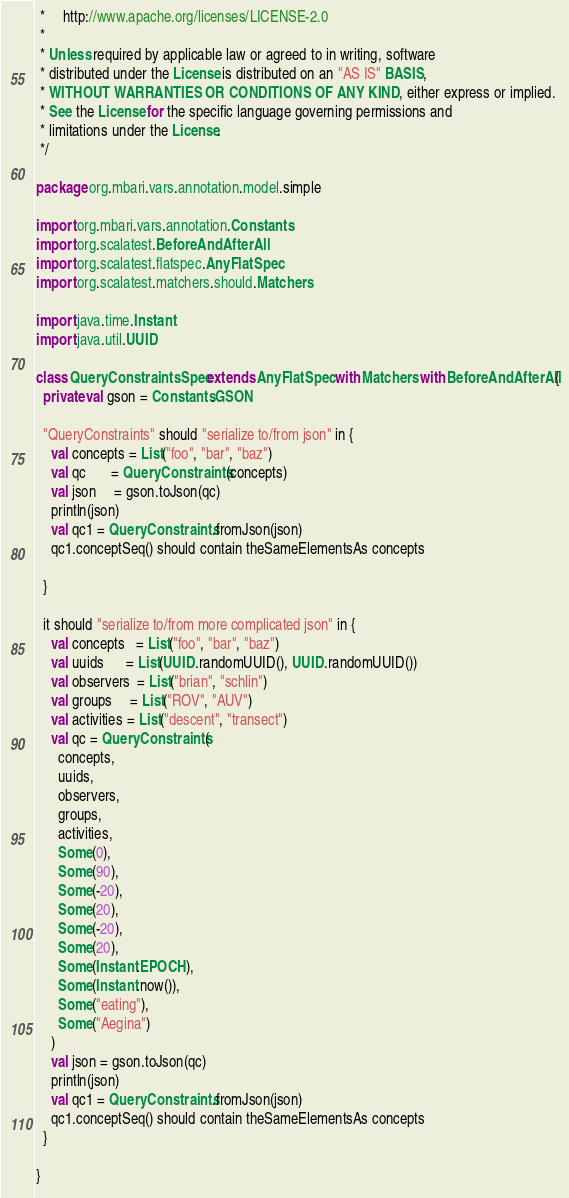<code> <loc_0><loc_0><loc_500><loc_500><_Scala_> *     http://www.apache.org/licenses/LICENSE-2.0
 *
 * Unless required by applicable law or agreed to in writing, software
 * distributed under the License is distributed on an "AS IS" BASIS,
 * WITHOUT WARRANTIES OR CONDITIONS OF ANY KIND, either express or implied.
 * See the License for the specific language governing permissions and
 * limitations under the License.
 */

package org.mbari.vars.annotation.model.simple

import org.mbari.vars.annotation.Constants
import org.scalatest.BeforeAndAfterAll
import org.scalatest.flatspec.AnyFlatSpec
import org.scalatest.matchers.should.Matchers

import java.time.Instant
import java.util.UUID

class QueryConstraintsSpec extends AnyFlatSpec with Matchers with BeforeAndAfterAll {
  private val gson = Constants.GSON

  "QueryConstraints" should "serialize to/from json" in {
    val concepts = List("foo", "bar", "baz")
    val qc       = QueryConstraints(concepts)
    val json     = gson.toJson(qc)
    println(json)
    val qc1 = QueryConstraints.fromJson(json)
    qc1.conceptSeq() should contain theSameElementsAs concepts

  }

  it should "serialize to/from more complicated json" in {
    val concepts   = List("foo", "bar", "baz")
    val uuids      = List(UUID.randomUUID(), UUID.randomUUID())
    val observers  = List("brian", "schlin")
    val groups     = List("ROV", "AUV")
    val activities = List("descent", "transect")
    val qc = QueryConstraints(
      concepts,
      uuids,
      observers,
      groups,
      activities,
      Some(0),
      Some(90),
      Some(-20),
      Some(20),
      Some(-20),
      Some(20),
      Some(Instant.EPOCH),
      Some(Instant.now()),
      Some("eating"),
      Some("Aegina")
    )
    val json = gson.toJson(qc)
    println(json)
    val qc1 = QueryConstraints.fromJson(json)
    qc1.conceptSeq() should contain theSameElementsAs concepts
  }

}
</code> 